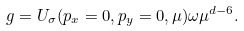Convert formula to latex. <formula><loc_0><loc_0><loc_500><loc_500>g = U _ { \sigma } ( p _ { x } = 0 , p _ { y } = 0 , \mu ) \omega \mu ^ { d - 6 } .</formula> 